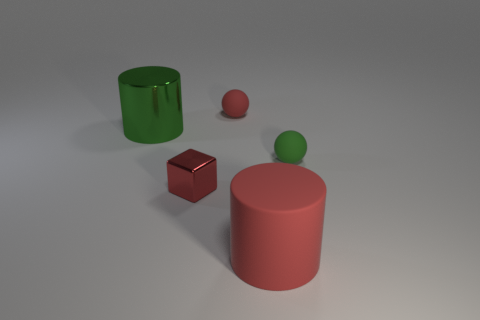Does the big red thing have the same shape as the big metal object?
Provide a short and direct response. Yes. There is a large green cylinder; how many red shiny blocks are in front of it?
Provide a succinct answer. 1. What is the shape of the big object in front of the green object on the right side of the cube?
Offer a terse response. Cylinder. There is a small green thing that is made of the same material as the tiny red sphere; what shape is it?
Your answer should be very brief. Sphere. Does the green object that is to the right of the tiny shiny object have the same size as the rubber sphere left of the small green matte object?
Offer a terse response. Yes. The small thing that is behind the green shiny cylinder has what shape?
Ensure brevity in your answer.  Sphere. What color is the big rubber thing?
Offer a very short reply. Red. There is a red metallic object; does it have the same size as the rubber thing that is to the right of the large rubber cylinder?
Give a very brief answer. Yes. How many metallic things are cylinders or red blocks?
Provide a short and direct response. 2. Are there any other things that have the same material as the big green cylinder?
Ensure brevity in your answer.  Yes. 